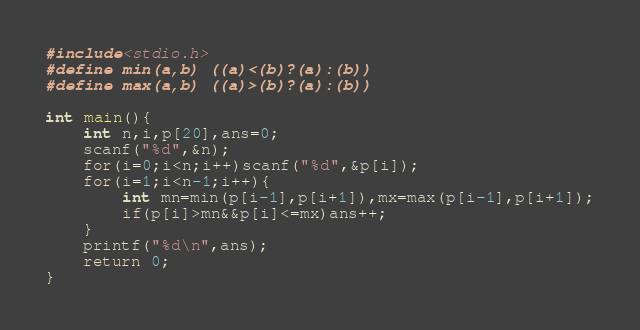<code> <loc_0><loc_0><loc_500><loc_500><_C_>#include<stdio.h>
#define min(a,b) ((a)<(b)?(a):(b))
#define max(a,b) ((a)>(b)?(a):(b))

int main(){
	int n,i,p[20],ans=0;
	scanf("%d",&n);
	for(i=0;i<n;i++)scanf("%d",&p[i]);
	for(i=1;i<n-1;i++){
		int mn=min(p[i-1],p[i+1]),mx=max(p[i-1],p[i+1]);
		if(p[i]>mn&&p[i]<=mx)ans++;
	}
	printf("%d\n",ans);
	return 0;
}</code> 